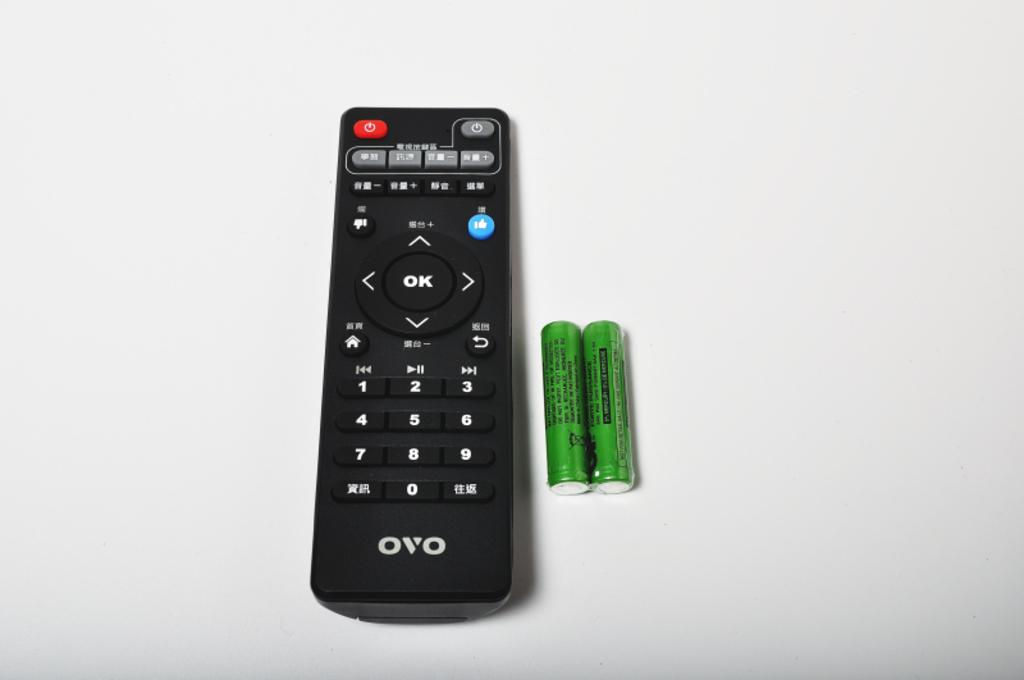<image>
Share a concise interpretation of the image provided. A black ovo remote with two green batteries next to it. 